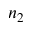<formula> <loc_0><loc_0><loc_500><loc_500>n _ { 2 }</formula> 